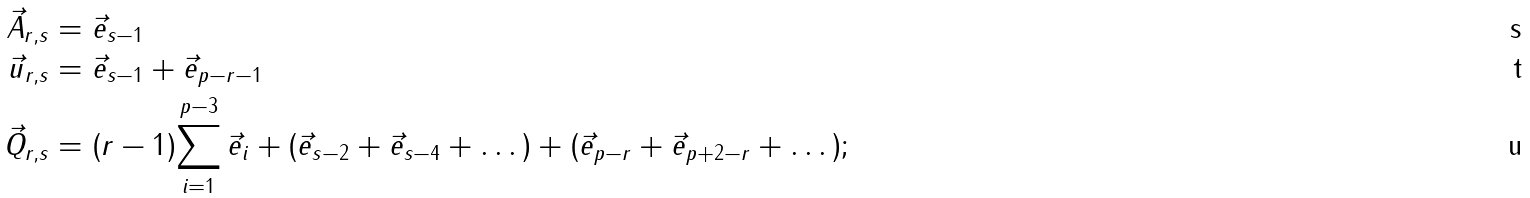<formula> <loc_0><loc_0><loc_500><loc_500>\vec { A } _ { r , s } & = \vec { e } _ { s - 1 } \\ \vec { u } _ { r , s } & = \vec { e } _ { s - 1 } + \vec { e } _ { p - r - 1 } \\ \vec { Q } _ { r , s } & = ( r - 1 ) { \sum _ { i = 1 } ^ { p - 3 } \vec { e } _ { i } } + ( \vec { e } _ { s - 2 } + \vec { e } _ { s - 4 } + \dots ) + ( \vec { e } _ { p - r } + \vec { e } _ { p + 2 - r } + \dots ) ;</formula> 